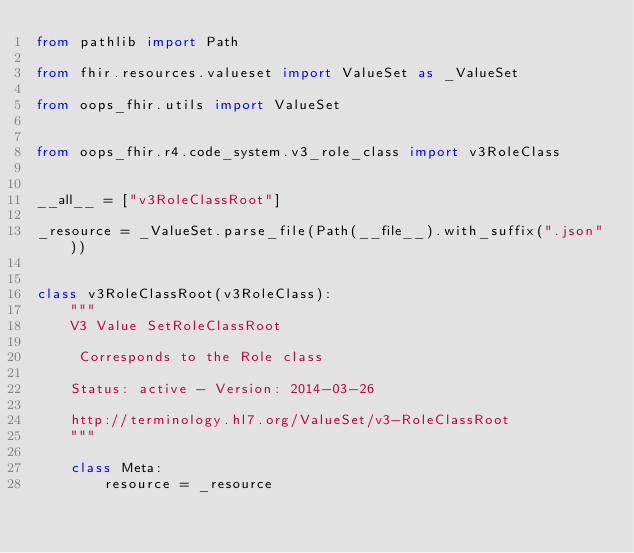<code> <loc_0><loc_0><loc_500><loc_500><_Python_>from pathlib import Path

from fhir.resources.valueset import ValueSet as _ValueSet

from oops_fhir.utils import ValueSet


from oops_fhir.r4.code_system.v3_role_class import v3RoleClass


__all__ = ["v3RoleClassRoot"]

_resource = _ValueSet.parse_file(Path(__file__).with_suffix(".json"))


class v3RoleClassRoot(v3RoleClass):
    """
    V3 Value SetRoleClassRoot

     Corresponds to the Role class

    Status: active - Version: 2014-03-26

    http://terminology.hl7.org/ValueSet/v3-RoleClassRoot
    """

    class Meta:
        resource = _resource
</code> 